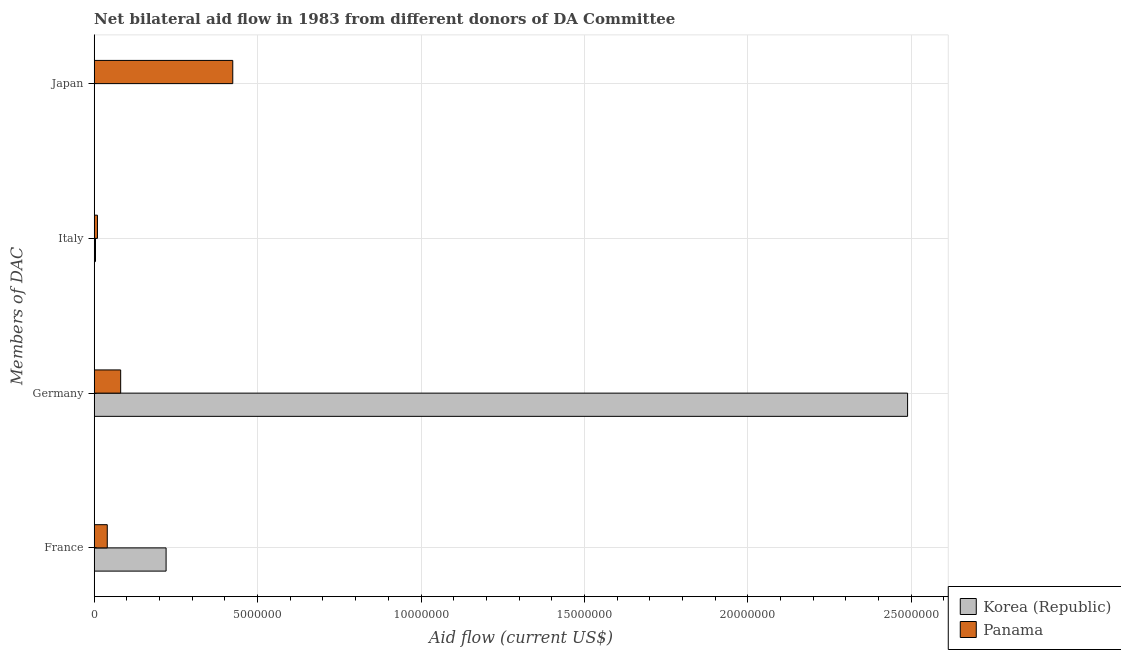How many different coloured bars are there?
Your answer should be compact. 2. Are the number of bars per tick equal to the number of legend labels?
Offer a very short reply. No. Are the number of bars on each tick of the Y-axis equal?
Give a very brief answer. No. How many bars are there on the 1st tick from the bottom?
Provide a short and direct response. 2. What is the label of the 3rd group of bars from the top?
Your answer should be very brief. Germany. What is the amount of aid given by japan in Korea (Republic)?
Make the answer very short. 0. Across all countries, what is the maximum amount of aid given by germany?
Ensure brevity in your answer.  2.49e+07. In which country was the amount of aid given by germany maximum?
Keep it short and to the point. Korea (Republic). What is the total amount of aid given by france in the graph?
Keep it short and to the point. 2.60e+06. What is the difference between the amount of aid given by italy in Panama and that in Korea (Republic)?
Make the answer very short. 6.00e+04. What is the difference between the amount of aid given by japan in Panama and the amount of aid given by italy in Korea (Republic)?
Your answer should be very brief. 4.20e+06. What is the average amount of aid given by japan per country?
Your answer should be very brief. 2.12e+06. What is the difference between the amount of aid given by france and amount of aid given by germany in Panama?
Keep it short and to the point. -4.10e+05. What is the ratio of the amount of aid given by italy in Panama to that in Korea (Republic)?
Provide a succinct answer. 2.5. Is the amount of aid given by germany in Panama less than that in Korea (Republic)?
Offer a very short reply. Yes. What is the difference between the highest and the second highest amount of aid given by italy?
Your response must be concise. 6.00e+04. What is the difference between the highest and the lowest amount of aid given by germany?
Provide a succinct answer. 2.41e+07. In how many countries, is the amount of aid given by italy greater than the average amount of aid given by italy taken over all countries?
Your response must be concise. 1. Is the sum of the amount of aid given by france in Panama and Korea (Republic) greater than the maximum amount of aid given by japan across all countries?
Your answer should be compact. No. Is it the case that in every country, the sum of the amount of aid given by germany and amount of aid given by france is greater than the sum of amount of aid given by italy and amount of aid given by japan?
Your answer should be compact. Yes. Is it the case that in every country, the sum of the amount of aid given by france and amount of aid given by germany is greater than the amount of aid given by italy?
Your answer should be compact. Yes. Are all the bars in the graph horizontal?
Your response must be concise. Yes. How many countries are there in the graph?
Your response must be concise. 2. What is the difference between two consecutive major ticks on the X-axis?
Offer a terse response. 5.00e+06. Does the graph contain any zero values?
Offer a very short reply. Yes. Does the graph contain grids?
Ensure brevity in your answer.  Yes. What is the title of the graph?
Make the answer very short. Net bilateral aid flow in 1983 from different donors of DA Committee. What is the label or title of the Y-axis?
Your response must be concise. Members of DAC. What is the Aid flow (current US$) in Korea (Republic) in France?
Keep it short and to the point. 2.20e+06. What is the Aid flow (current US$) in Korea (Republic) in Germany?
Give a very brief answer. 2.49e+07. What is the Aid flow (current US$) in Panama in Germany?
Offer a very short reply. 8.10e+05. What is the Aid flow (current US$) of Panama in Italy?
Your answer should be very brief. 1.00e+05. What is the Aid flow (current US$) in Panama in Japan?
Offer a terse response. 4.24e+06. Across all Members of DAC, what is the maximum Aid flow (current US$) in Korea (Republic)?
Your answer should be compact. 2.49e+07. Across all Members of DAC, what is the maximum Aid flow (current US$) of Panama?
Your answer should be very brief. 4.24e+06. What is the total Aid flow (current US$) of Korea (Republic) in the graph?
Offer a very short reply. 2.71e+07. What is the total Aid flow (current US$) in Panama in the graph?
Your answer should be compact. 5.55e+06. What is the difference between the Aid flow (current US$) in Korea (Republic) in France and that in Germany?
Offer a very short reply. -2.27e+07. What is the difference between the Aid flow (current US$) in Panama in France and that in Germany?
Provide a succinct answer. -4.10e+05. What is the difference between the Aid flow (current US$) of Korea (Republic) in France and that in Italy?
Offer a terse response. 2.16e+06. What is the difference between the Aid flow (current US$) of Panama in France and that in Italy?
Your answer should be compact. 3.00e+05. What is the difference between the Aid flow (current US$) of Panama in France and that in Japan?
Provide a short and direct response. -3.84e+06. What is the difference between the Aid flow (current US$) of Korea (Republic) in Germany and that in Italy?
Your answer should be compact. 2.48e+07. What is the difference between the Aid flow (current US$) of Panama in Germany and that in Italy?
Your answer should be very brief. 7.10e+05. What is the difference between the Aid flow (current US$) in Panama in Germany and that in Japan?
Provide a short and direct response. -3.43e+06. What is the difference between the Aid flow (current US$) of Panama in Italy and that in Japan?
Make the answer very short. -4.14e+06. What is the difference between the Aid flow (current US$) of Korea (Republic) in France and the Aid flow (current US$) of Panama in Germany?
Ensure brevity in your answer.  1.39e+06. What is the difference between the Aid flow (current US$) of Korea (Republic) in France and the Aid flow (current US$) of Panama in Italy?
Offer a terse response. 2.10e+06. What is the difference between the Aid flow (current US$) in Korea (Republic) in France and the Aid flow (current US$) in Panama in Japan?
Ensure brevity in your answer.  -2.04e+06. What is the difference between the Aid flow (current US$) of Korea (Republic) in Germany and the Aid flow (current US$) of Panama in Italy?
Ensure brevity in your answer.  2.48e+07. What is the difference between the Aid flow (current US$) in Korea (Republic) in Germany and the Aid flow (current US$) in Panama in Japan?
Provide a succinct answer. 2.06e+07. What is the difference between the Aid flow (current US$) of Korea (Republic) in Italy and the Aid flow (current US$) of Panama in Japan?
Your response must be concise. -4.20e+06. What is the average Aid flow (current US$) of Korea (Republic) per Members of DAC?
Provide a short and direct response. 6.78e+06. What is the average Aid flow (current US$) in Panama per Members of DAC?
Provide a succinct answer. 1.39e+06. What is the difference between the Aid flow (current US$) of Korea (Republic) and Aid flow (current US$) of Panama in France?
Your response must be concise. 1.80e+06. What is the difference between the Aid flow (current US$) in Korea (Republic) and Aid flow (current US$) in Panama in Germany?
Your answer should be compact. 2.41e+07. What is the ratio of the Aid flow (current US$) in Korea (Republic) in France to that in Germany?
Your response must be concise. 0.09. What is the ratio of the Aid flow (current US$) of Panama in France to that in Germany?
Make the answer very short. 0.49. What is the ratio of the Aid flow (current US$) of Panama in France to that in Italy?
Keep it short and to the point. 4. What is the ratio of the Aid flow (current US$) in Panama in France to that in Japan?
Your response must be concise. 0.09. What is the ratio of the Aid flow (current US$) in Korea (Republic) in Germany to that in Italy?
Provide a short and direct response. 622.25. What is the ratio of the Aid flow (current US$) in Panama in Germany to that in Italy?
Provide a short and direct response. 8.1. What is the ratio of the Aid flow (current US$) of Panama in Germany to that in Japan?
Keep it short and to the point. 0.19. What is the ratio of the Aid flow (current US$) of Panama in Italy to that in Japan?
Make the answer very short. 0.02. What is the difference between the highest and the second highest Aid flow (current US$) in Korea (Republic)?
Give a very brief answer. 2.27e+07. What is the difference between the highest and the second highest Aid flow (current US$) of Panama?
Make the answer very short. 3.43e+06. What is the difference between the highest and the lowest Aid flow (current US$) in Korea (Republic)?
Give a very brief answer. 2.49e+07. What is the difference between the highest and the lowest Aid flow (current US$) of Panama?
Offer a very short reply. 4.14e+06. 